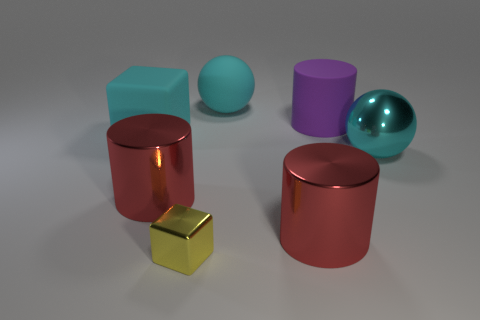Add 1 metal blocks. How many objects exist? 8 Subtract all balls. How many objects are left? 5 Subtract all green cubes. Subtract all red cylinders. How many objects are left? 5 Add 2 large cyan matte spheres. How many large cyan matte spheres are left? 3 Add 2 red things. How many red things exist? 4 Subtract 0 cyan cylinders. How many objects are left? 7 